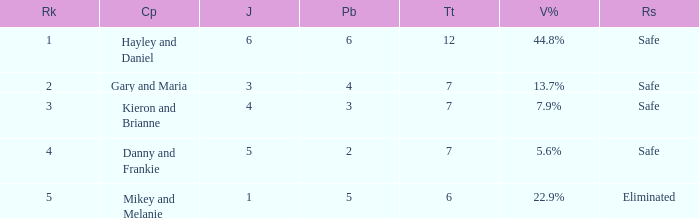What was the total number when the vote percentage was 44.8%? 1.0. 